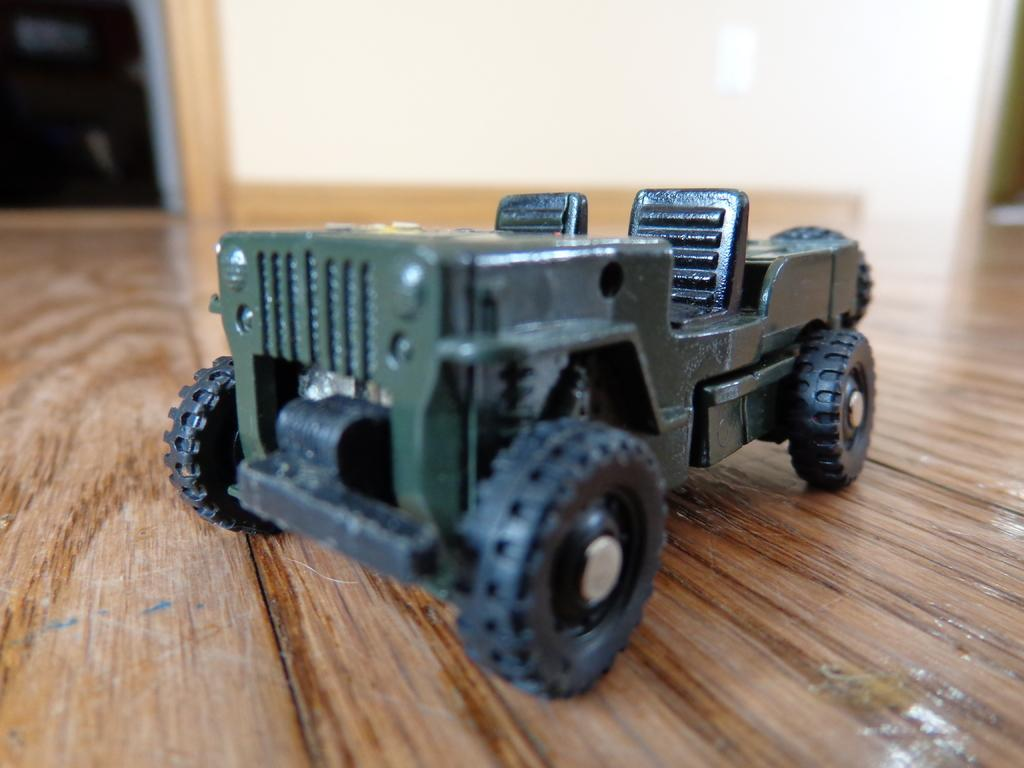What object is on the floor in the image? There is a toy vehicle on the floor in the image. Can you describe the background of the image? The background of the image is blurry. What type of cabbage is growing on the patch in the image? There is no cabbage or patch present in the image; it features a toy vehicle on the floor with a blurry background. 